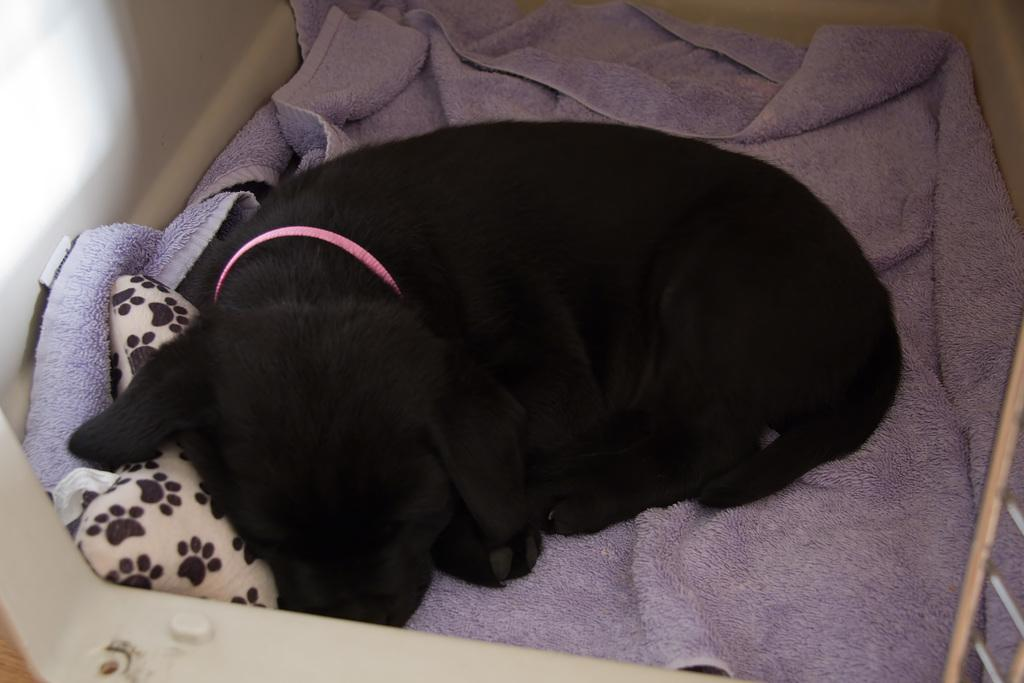What type of animal is in the image? There is a black dog in the image. What is the dog resting on? The dog is on a cloth. What can be seen on the left side of the image? There is a wall on the left side of the image. How many lizards can be seen interacting with the dog in the image? There are no lizards present in the image; it features a black dog on a cloth with a wall on the left side. 